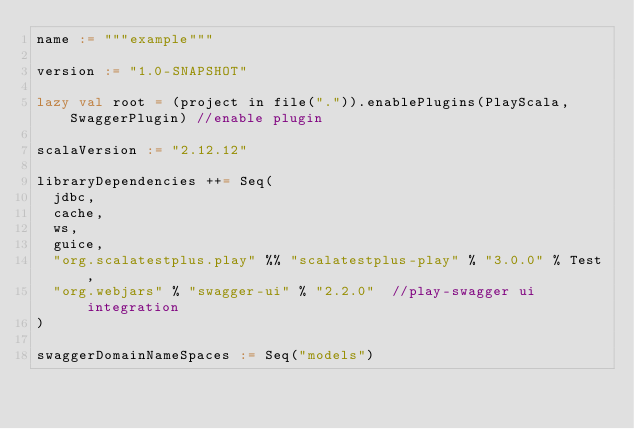Convert code to text. <code><loc_0><loc_0><loc_500><loc_500><_Scala_>name := """example"""

version := "1.0-SNAPSHOT"

lazy val root = (project in file(".")).enablePlugins(PlayScala, SwaggerPlugin) //enable plugin

scalaVersion := "2.12.12"

libraryDependencies ++= Seq(
  jdbc,
  cache,
  ws,
  guice,
  "org.scalatestplus.play" %% "scalatestplus-play" % "3.0.0" % Test,
  "org.webjars" % "swagger-ui" % "2.2.0"  //play-swagger ui integration
)

swaggerDomainNameSpaces := Seq("models")

</code> 